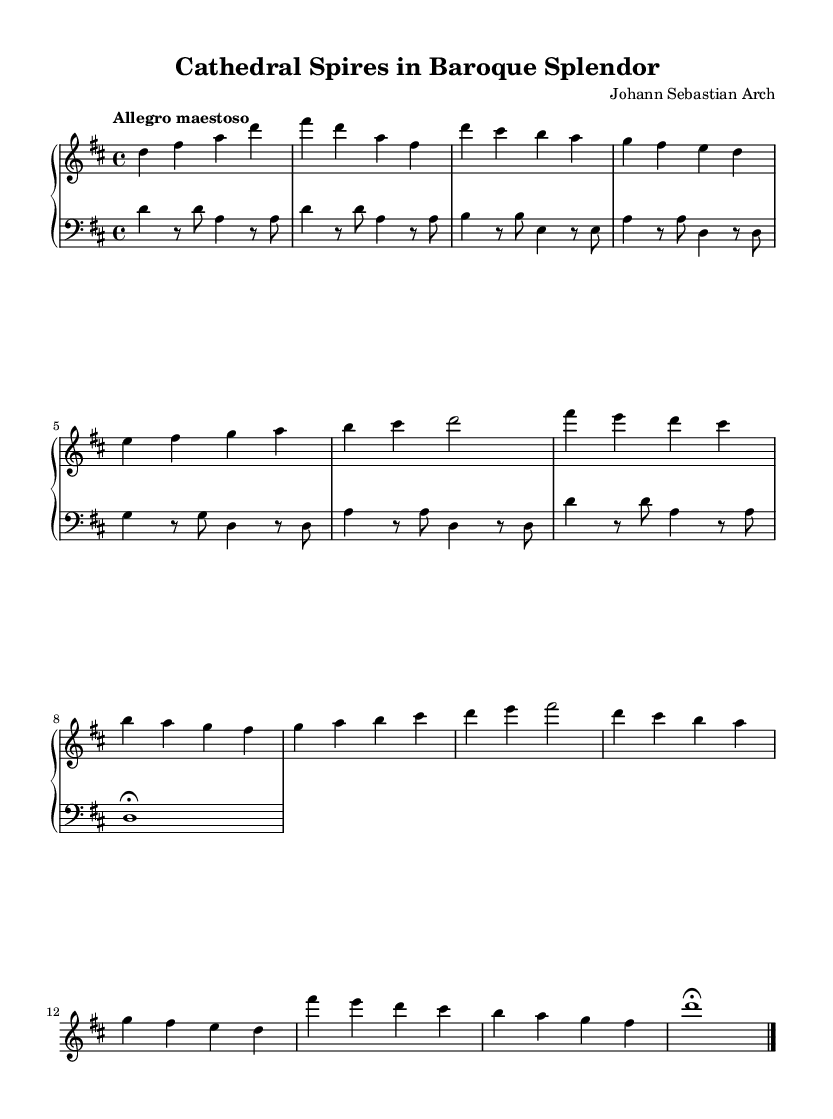What is the key signature of this music? The key signature is two sharps, indicating that the piece is in D major. This can be verified by looking at the key signature at the beginning of the score, which shows two sharp symbols on the F and C lines.
Answer: D major What is the time signature of this piece? The time signature is 4/4, which is indicated at the beginning of the score. This means there are four beats in each measure, with a quarter note receiving one beat. Is deduced from the two numbers placed in the time signature section of the score.
Answer: 4/4 What is the tempo marking for this piece? The tempo marking is "Allegro maestoso," which instructs the performer to play the piece in a fast and majestic manner. This is typically noted at the beginning of the music score, right after the time signature.
Answer: Allegro maestoso How many themes are presented in the composition? There are two themes presented, labeled as Theme A and Theme B in the sheet music. The existence of these themes is indicated by the distinct sections of the music that are highlighted and titled accordingly.
Answer: Two What is the last note played in this composition? The last note played in this composition is a D, which is indicated by the note at the end of the score, specifically marked with a fermata indicating it should be held longer than its typical value.
Answer: D What is the primary instrument indicated for this score? The primary instrument indicated for this score is the church organ, as stated in the staff designation for both the right and left hand, where it mentions "midiInstrument = church organ."
Answer: Church organ What expresses the architectural theme in this music? The title "Cathedral Spires in Baroque Splendor" directly expresses the architectural theme by linking the music to the imagery and grandeur associated with cathedrals, reflecting the Baroque style's focus on dramatic elements. This connection is drawn from the title of the piece itself.
Answer: Cathedral Spires 